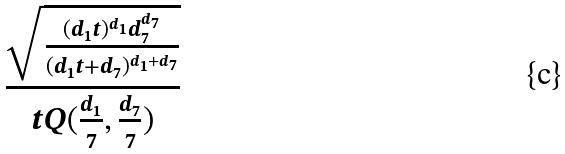<formula> <loc_0><loc_0><loc_500><loc_500>\frac { \sqrt { \frac { ( d _ { 1 } t ) ^ { d _ { 1 } } d _ { 7 } ^ { d _ { 7 } } } { ( d _ { 1 } t + d _ { 7 } ) ^ { d _ { 1 } + d _ { 7 } } } } } { t Q ( \frac { d _ { 1 } } { 7 } , \frac { d _ { 7 } } { 7 } ) }</formula> 